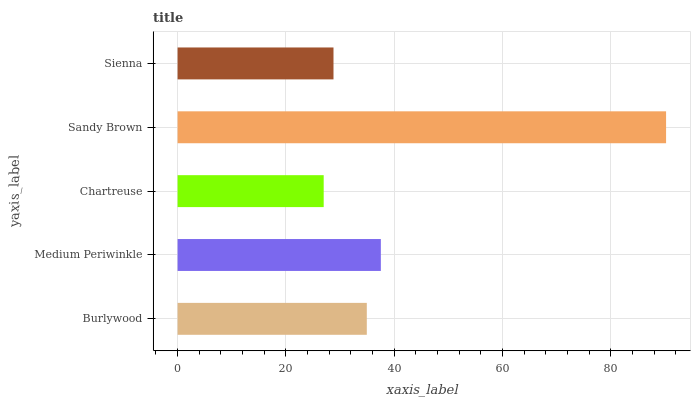Is Chartreuse the minimum?
Answer yes or no. Yes. Is Sandy Brown the maximum?
Answer yes or no. Yes. Is Medium Periwinkle the minimum?
Answer yes or no. No. Is Medium Periwinkle the maximum?
Answer yes or no. No. Is Medium Periwinkle greater than Burlywood?
Answer yes or no. Yes. Is Burlywood less than Medium Periwinkle?
Answer yes or no. Yes. Is Burlywood greater than Medium Periwinkle?
Answer yes or no. No. Is Medium Periwinkle less than Burlywood?
Answer yes or no. No. Is Burlywood the high median?
Answer yes or no. Yes. Is Burlywood the low median?
Answer yes or no. Yes. Is Chartreuse the high median?
Answer yes or no. No. Is Sandy Brown the low median?
Answer yes or no. No. 